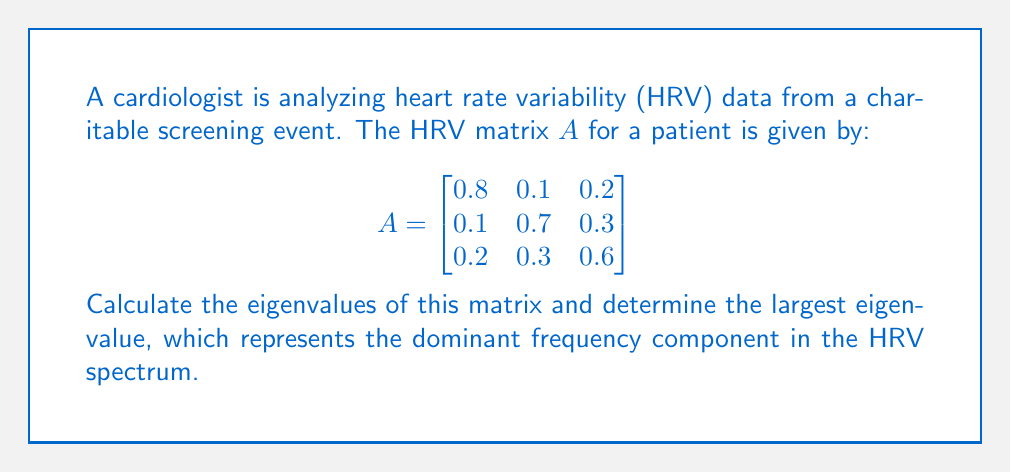Show me your answer to this math problem. To find the eigenvalues of matrix $A$, we need to solve the characteristic equation:

$\det(A - \lambda I) = 0$

where $I$ is the 3x3 identity matrix and $\lambda$ represents the eigenvalues.

Step 1: Set up the characteristic equation:
$$\det\begin{pmatrix}
0.8-\lambda & 0.1 & 0.2 \\
0.1 & 0.7-\lambda & 0.3 \\
0.2 & 0.3 & 0.6-\lambda
\end{pmatrix} = 0$$

Step 2: Expand the determinant:
$$(0.8-\lambda)[(0.7-\lambda)(0.6-\lambda) - 0.09] - 0.1[0.1(0.6-\lambda) - 0.06] + 0.2[0.03 - 0.1(0.7-\lambda)] = 0$$

Step 3: Simplify:
$$\lambda^3 - 2.1\lambda^2 + 1.37\lambda - 0.278 = 0$$

Step 4: Solve the cubic equation. This can be done using the cubic formula or numerical methods. The solutions are:

$\lambda_1 \approx 1.2191$
$\lambda_2 \approx 0.5385$
$\lambda_3 \approx 0.3424$

Step 5: Identify the largest eigenvalue:
The largest eigenvalue is $\lambda_1 \approx 1.2191$, which represents the dominant frequency component in the HRV spectrum.
Answer: $\lambda_1 \approx 1.2191$ 